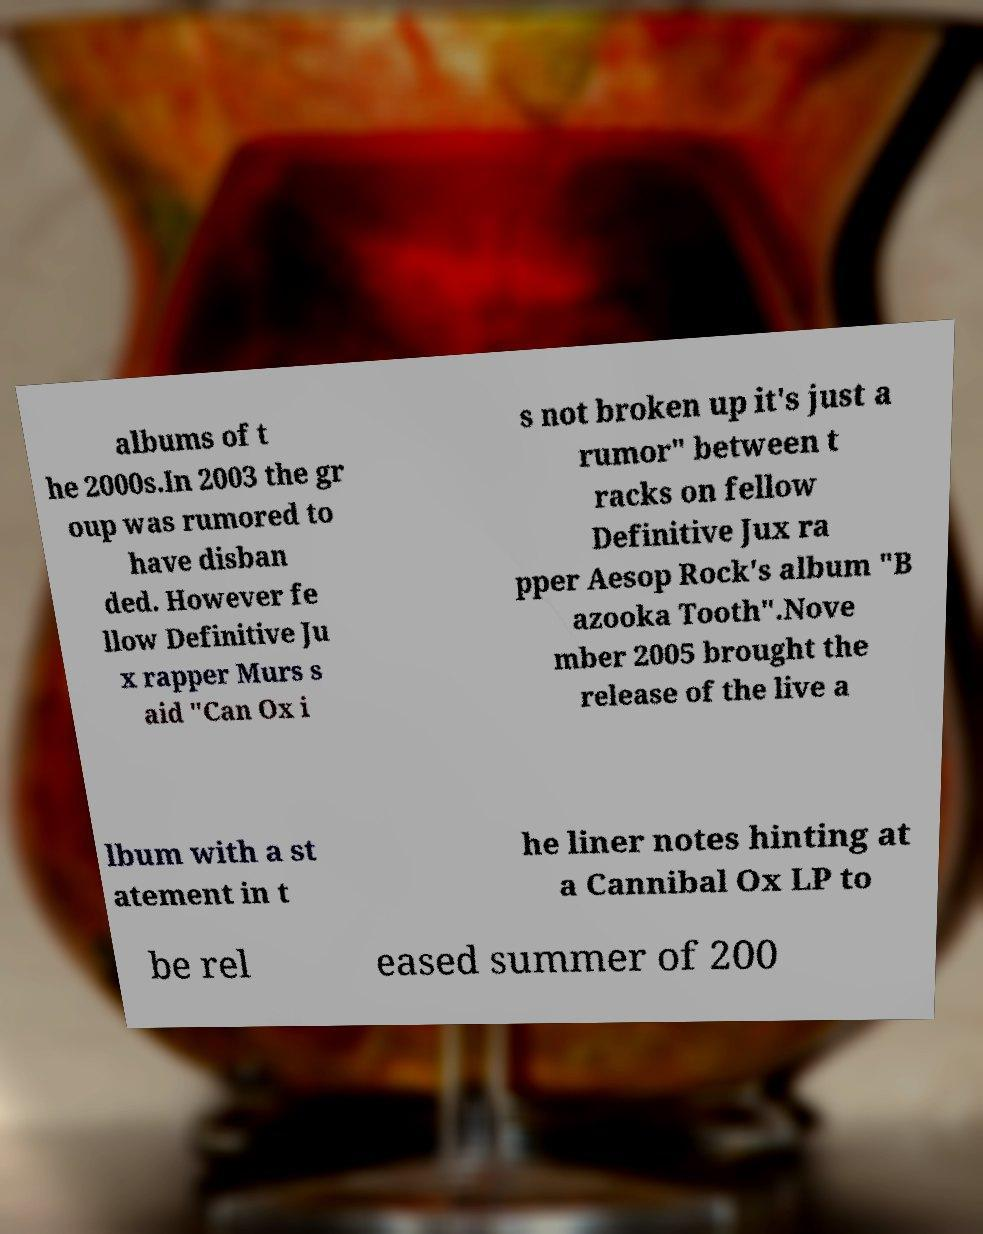Could you extract and type out the text from this image? albums of t he 2000s.In 2003 the gr oup was rumored to have disban ded. However fe llow Definitive Ju x rapper Murs s aid "Can Ox i s not broken up it's just a rumor" between t racks on fellow Definitive Jux ra pper Aesop Rock's album "B azooka Tooth".Nove mber 2005 brought the release of the live a lbum with a st atement in t he liner notes hinting at a Cannibal Ox LP to be rel eased summer of 200 